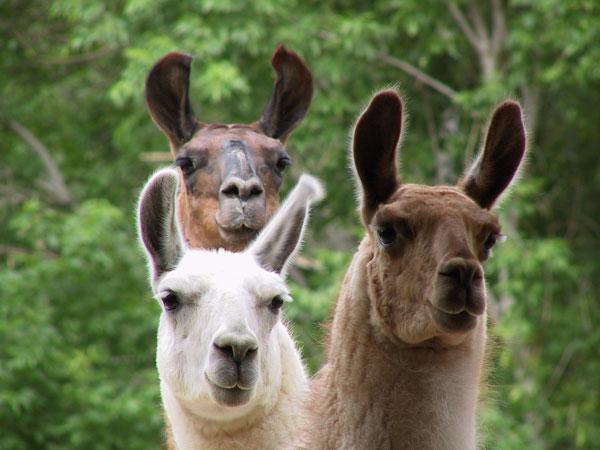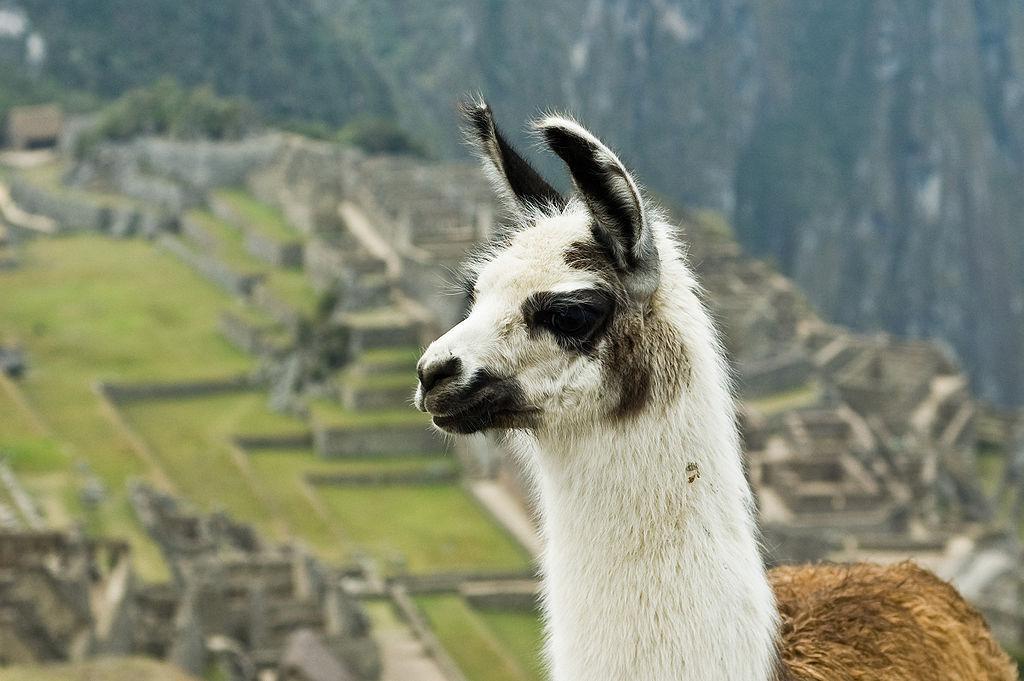The first image is the image on the left, the second image is the image on the right. Evaluate the accuracy of this statement regarding the images: "An image contains a llama clenching something in its mouth.". Is it true? Answer yes or no. No. The first image is the image on the left, the second image is the image on the right. Given the left and right images, does the statement "At least one llama is eating food." hold true? Answer yes or no. No. 